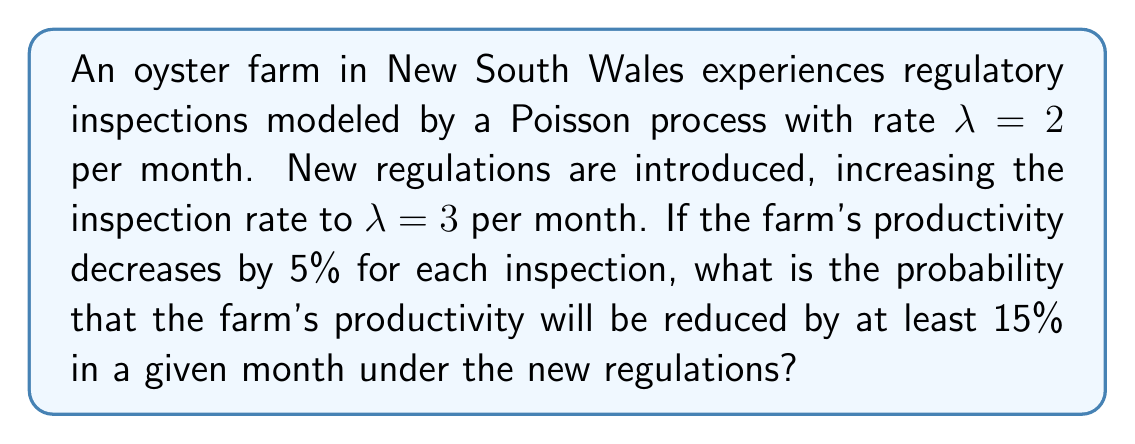Provide a solution to this math problem. Let's approach this step-by-step:

1) The number of inspections in a month follows a Poisson distribution with rate $\lambda = 3$.

2) We need to find the probability of having at least 3 inspections in a month, as 3 inspections would result in a 15% reduction in productivity (5% per inspection).

3) Let X be the number of inspections in a month. We need to calculate:

   $P(X \geq 3) = 1 - P(X < 3) = 1 - [P(X = 0) + P(X = 1) + P(X = 2)]$

4) The probability mass function for a Poisson distribution is:

   $P(X = k) = \frac{e^{-\lambda}\lambda^k}{k!}$

5) Calculating each probability:

   $P(X = 0) = \frac{e^{-3}3^0}{0!} = e^{-3}$

   $P(X = 1) = \frac{e^{-3}3^1}{1!} = 3e^{-3}$

   $P(X = 2) = \frac{e^{-3}3^2}{2!} = \frac{9e^{-3}}{2}$

6) Now, we can calculate the probability:

   $P(X \geq 3) = 1 - [e^{-3} + 3e^{-3} + \frac{9e^{-3}}{2}]$

   $= 1 - e^{-3}(1 + 3 + \frac{9}{2})$

   $= 1 - \frac{13}{2}e^{-3}$

7) Calculating this value:

   $P(X \geq 3) \approx 0.8009$
Answer: $0.8009$ or approximately $80.09\%$ 